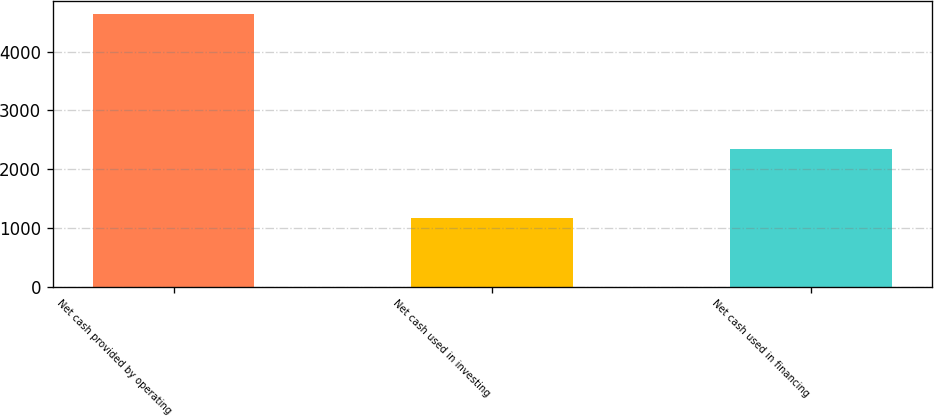Convert chart to OTSL. <chart><loc_0><loc_0><loc_500><loc_500><bar_chart><fcel>Net cash provided by operating<fcel>Net cash used in investing<fcel>Net cash used in financing<nl><fcel>4637<fcel>1163<fcel>2344<nl></chart> 